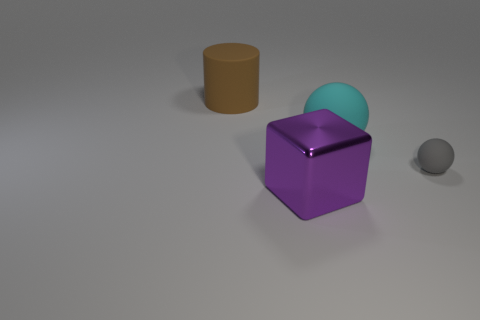Add 1 large things. How many objects exist? 5 Subtract all large purple things. Subtract all tiny cyan matte objects. How many objects are left? 3 Add 3 matte cylinders. How many matte cylinders are left? 4 Add 4 tiny brown metallic cylinders. How many tiny brown metallic cylinders exist? 4 Subtract 0 yellow balls. How many objects are left? 4 Subtract all cylinders. How many objects are left? 3 